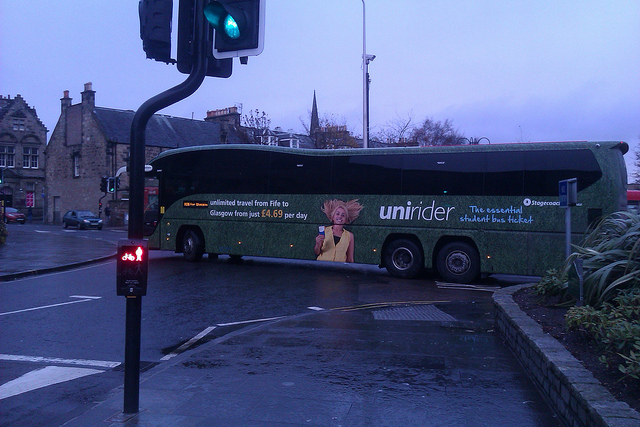Can you identify the location or place based on the surroundings? While the exact location cannot be determined from the image alone, the setting suggests an urban environment with a stone building and a noticeable church or spire in the background, hinting at a likely historical or central urban area. 